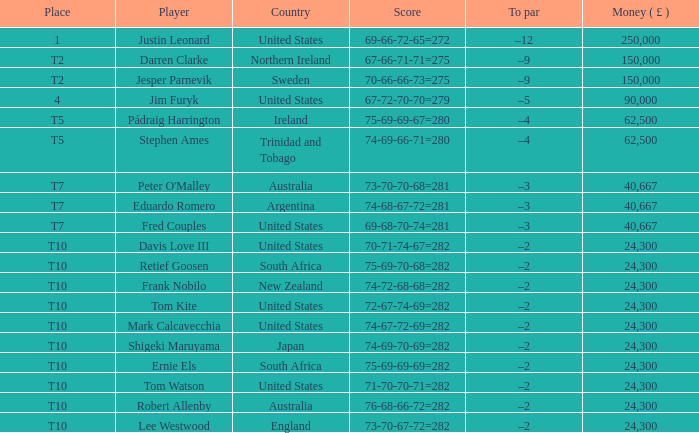How much money has been won by Stephen Ames? 62500.0. 